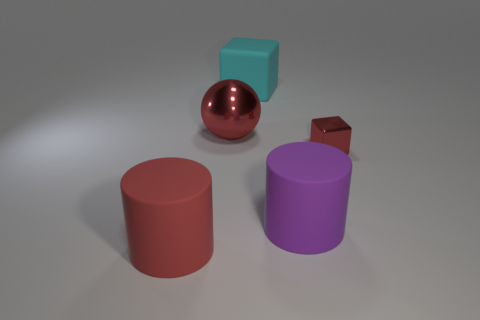There is a large cylinder that is the same color as the small cube; what material is it?
Ensure brevity in your answer.  Rubber. What size is the metal thing that is the same color as the big metal sphere?
Keep it short and to the point. Small. There is a cylinder in front of the purple cylinder; does it have the same size as the rubber cylinder behind the red cylinder?
Keep it short and to the point. Yes. What number of big things are either purple rubber things or cyan rubber balls?
Make the answer very short. 1. What is the material of the cylinder left of the big thing behind the ball?
Give a very brief answer. Rubber. What is the shape of the metal object that is the same color as the metal ball?
Your answer should be compact. Cube. Are there any big blue objects made of the same material as the small cube?
Offer a terse response. No. Is the big purple cylinder made of the same material as the block right of the cyan rubber block?
Your answer should be compact. No. What is the color of the other shiny thing that is the same size as the cyan thing?
Provide a short and direct response. Red. There is a cube behind the red metal thing on the right side of the big rubber block; how big is it?
Your response must be concise. Large. 